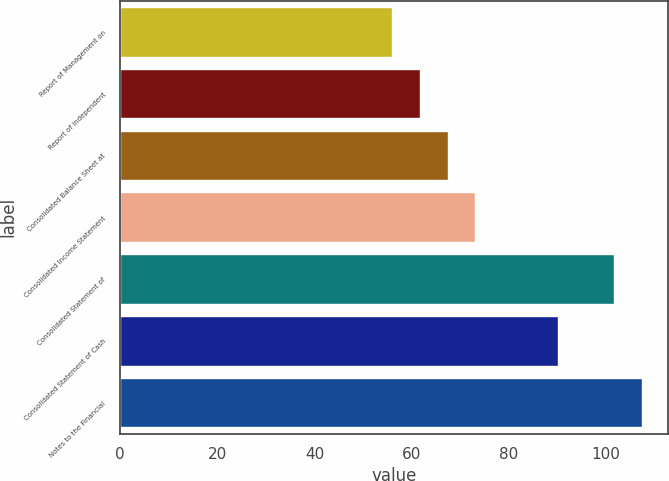<chart> <loc_0><loc_0><loc_500><loc_500><bar_chart><fcel>Report of Management on<fcel>Report of Independent<fcel>Consolidated Balance Sheet at<fcel>Consolidated Income Statement<fcel>Consolidated Statement of<fcel>Consolidated Statement of Cash<fcel>Notes to the Financial<nl><fcel>56<fcel>61.7<fcel>67.4<fcel>73.1<fcel>101.6<fcel>90.2<fcel>107.3<nl></chart> 